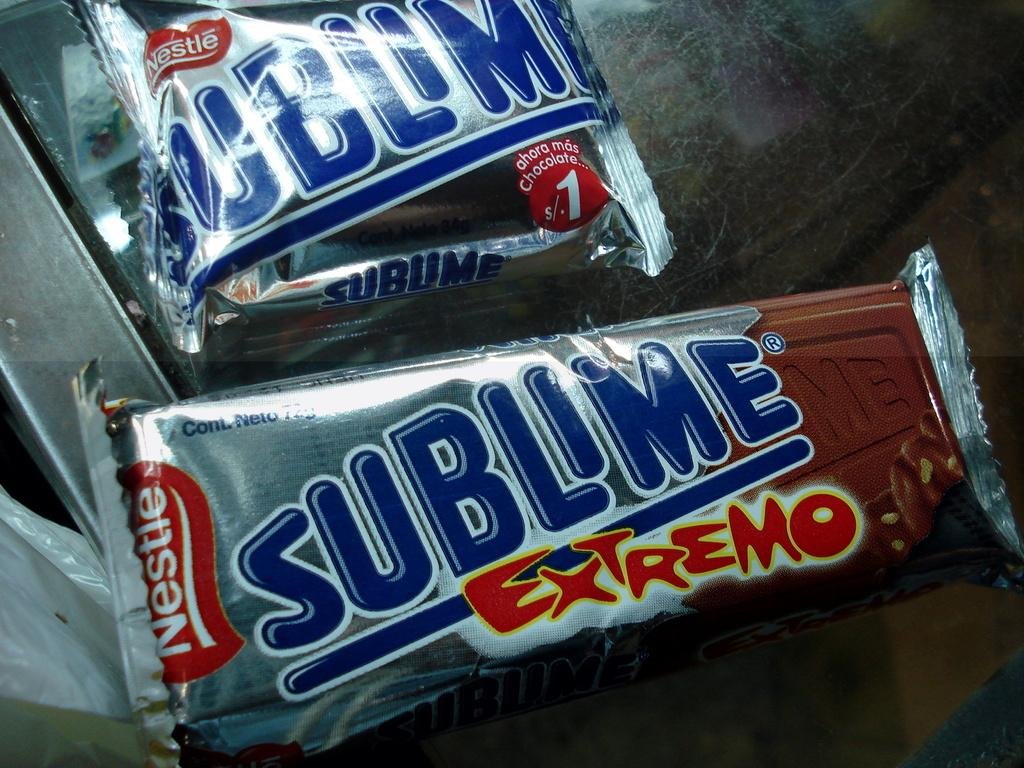<image>
Provide a brief description of the given image. A couple of Nestle Sublime bars, the front one is an Extremo. 